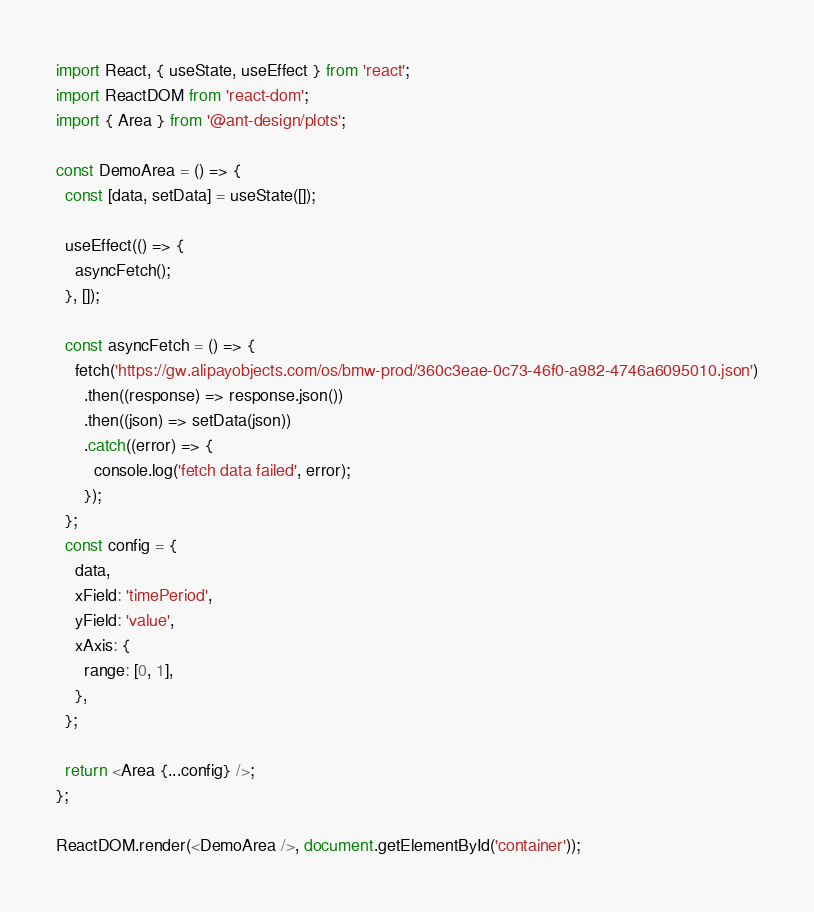Convert code to text. <code><loc_0><loc_0><loc_500><loc_500><_JavaScript_>import React, { useState, useEffect } from 'react';
import ReactDOM from 'react-dom';
import { Area } from '@ant-design/plots';

const DemoArea = () => {
  const [data, setData] = useState([]);

  useEffect(() => {
    asyncFetch();
  }, []);

  const asyncFetch = () => {
    fetch('https://gw.alipayobjects.com/os/bmw-prod/360c3eae-0c73-46f0-a982-4746a6095010.json')
      .then((response) => response.json())
      .then((json) => setData(json))
      .catch((error) => {
        console.log('fetch data failed', error);
      });
  };
  const config = {
    data,
    xField: 'timePeriod',
    yField: 'value',
    xAxis: {
      range: [0, 1],
    },
  };

  return <Area {...config} />;
};

ReactDOM.render(<DemoArea />, document.getElementById('container'));
</code> 